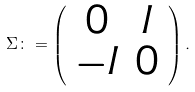<formula> <loc_0><loc_0><loc_500><loc_500>\Sigma \colon = \left ( \begin{array} { c c } 0 & I \\ - I & 0 \end{array} \right ) .</formula> 